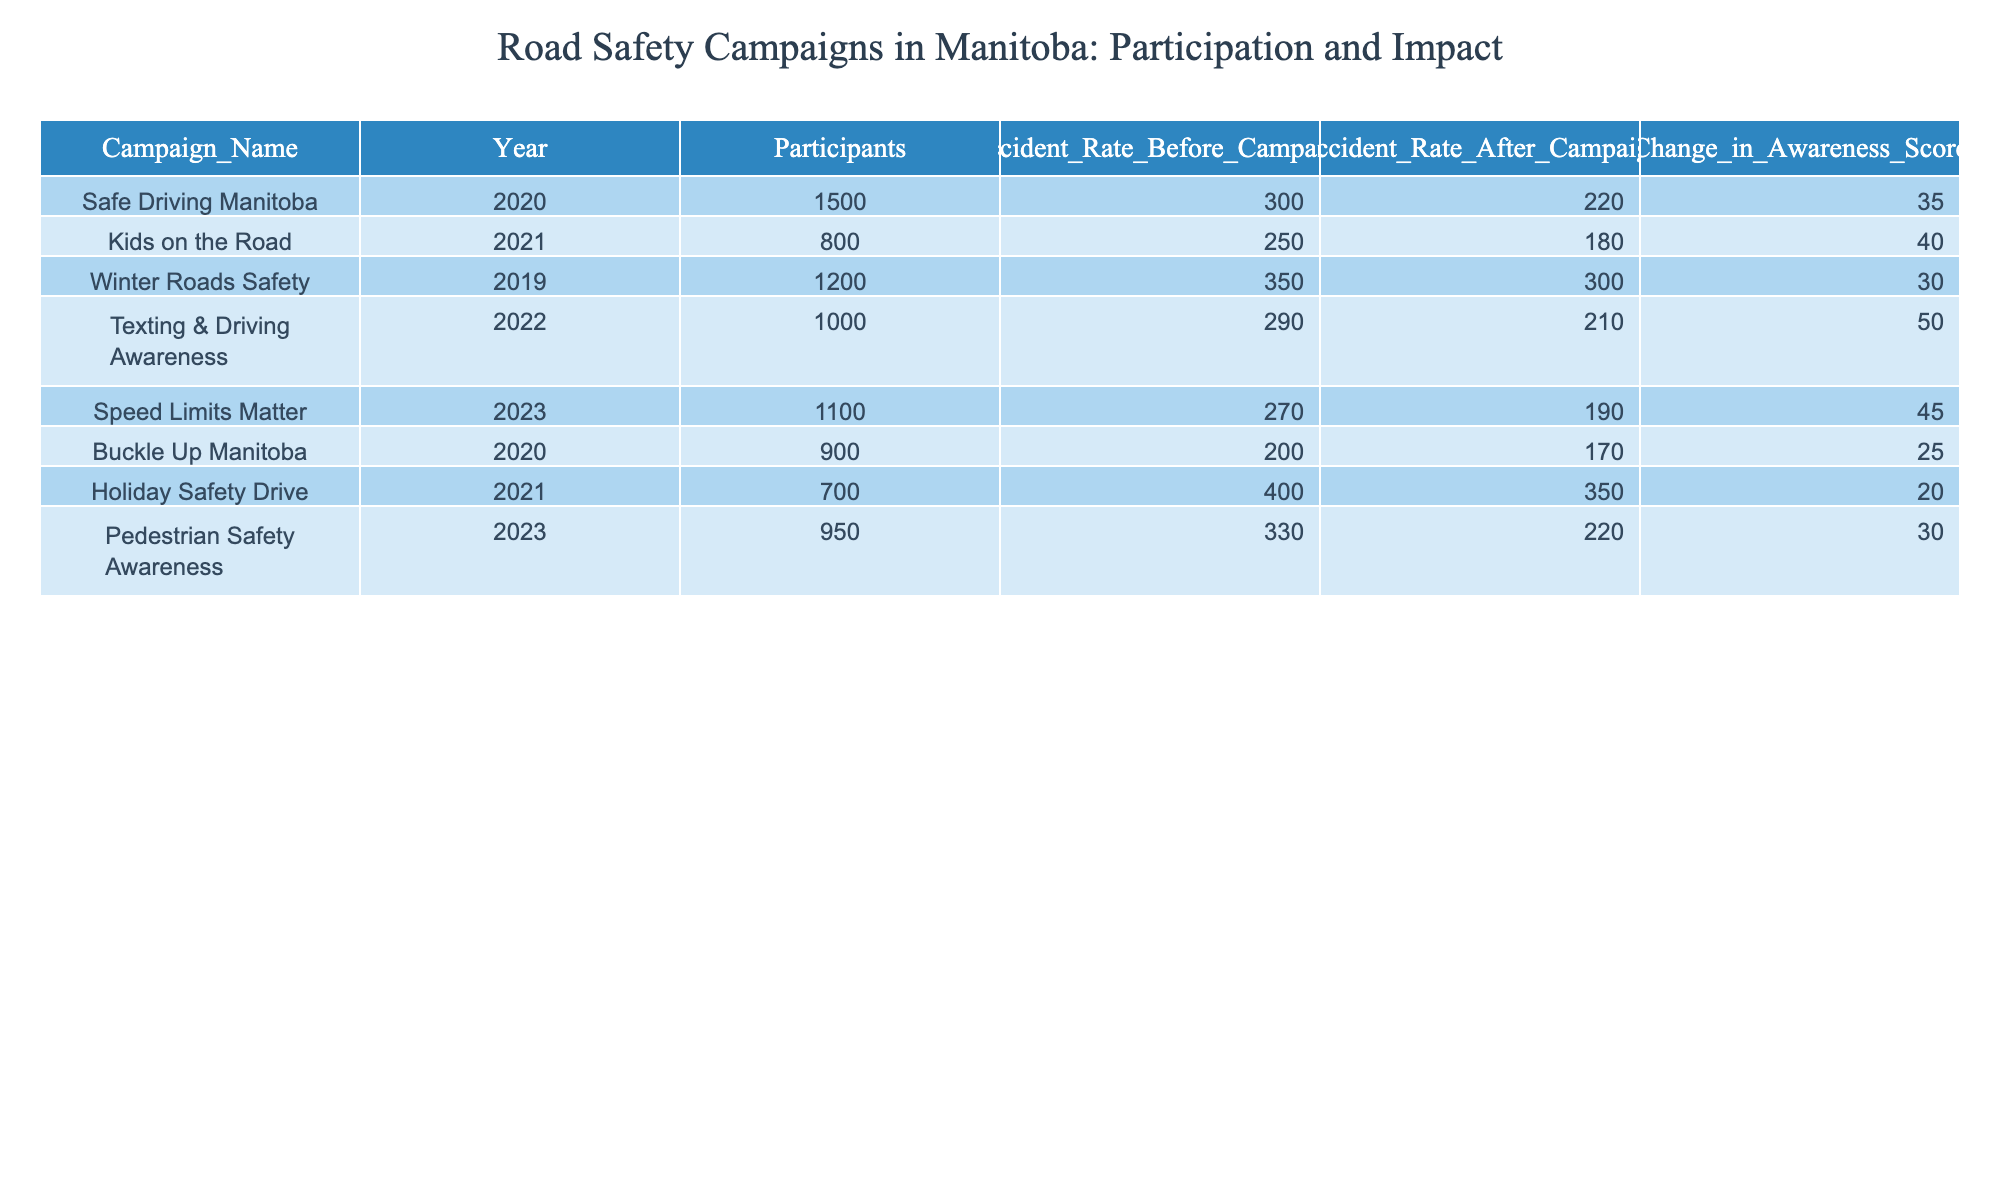What was the accident rate before the "Kids on the Road" campaign? Looking at the row corresponding to the "Kids on the Road" campaign, the accident rate before the campaign is listed as 250.
Answer: 250 Which campaign had the highest change in awareness score? The awareness score changes for each campaign are listed, and the highest value is 50, which corresponds to the "Texting & Driving Awareness" campaign.
Answer: 50 What is the average accident rate after all campaigns? To find the average accident rate after all campaigns, add the accident rates after each campaign: 220 + 180 + 300 + 210 + 190 + 170 + 350 + 220 = 1840. Then, divide by the number of campaigns, which is 8. Therefore, 1840 / 8 = 230.
Answer: 230 Did more participants attend the "Speed Limits Matter" campaign compared to the "Buckle Up Manitoba" campaign? The "Speed Limits Matter" campaign had 1100 participants, while the "Buckle Up Manitoba" campaign had 900 participants. Since 1100 is greater than 900, the answer is yes.
Answer: Yes What was the total reduction in accident rate from all the campaigns combined? To calculate the total reduction in accident rate from all campaigns, subtract the accident rates after the campaigns from the accident rates before the campaigns for each campaign, and then sum these reductions: (300 - 220) + (250 - 180) + (350 - 300) + (290 - 210) + (270 - 190) + (200 - 170) + (400 - 350) + (330 - 220) = 80 + 70 + 50 + 80 + 80 + 30 + 50 + 110 = 550.
Answer: 550 